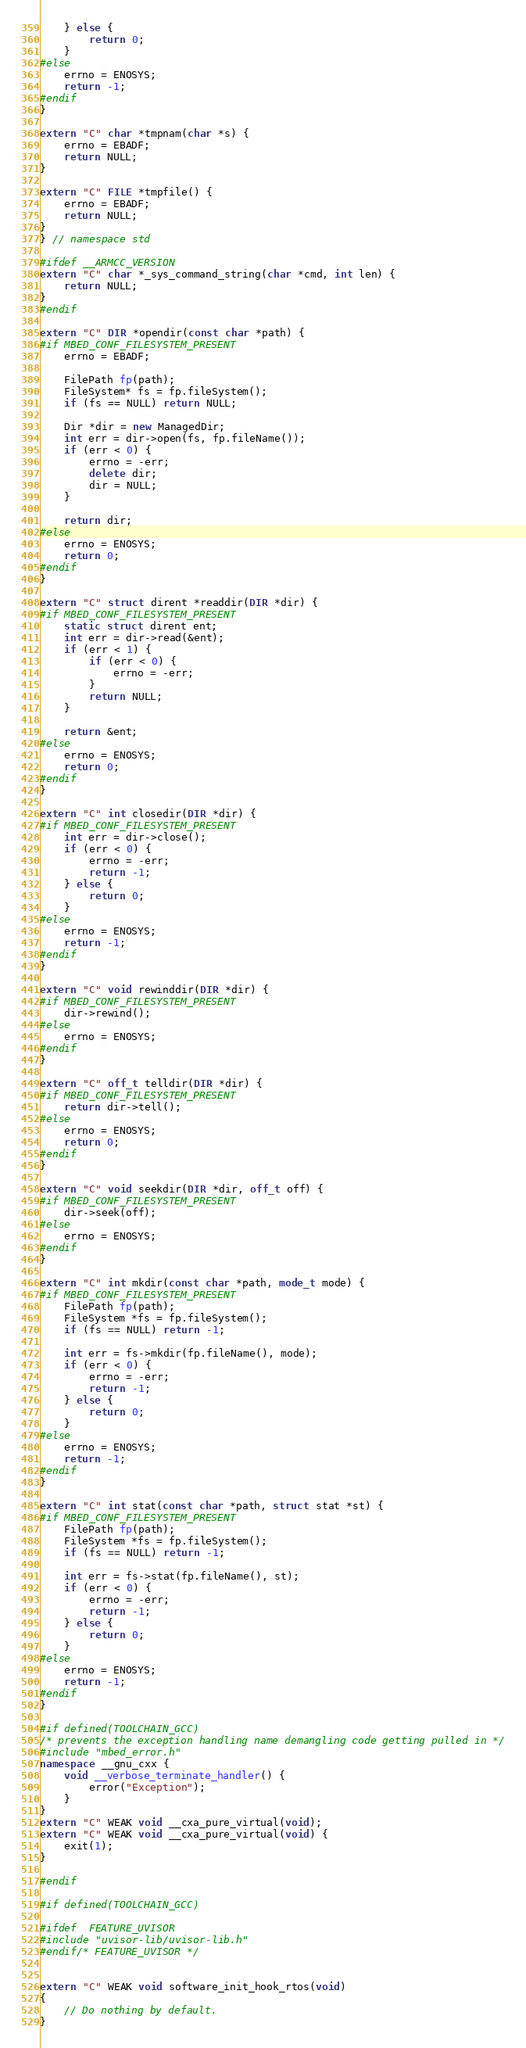Convert code to text. <code><loc_0><loc_0><loc_500><loc_500><_C++_>    } else {
        return 0;
    }
#else
    errno = ENOSYS;
    return -1;
#endif
}

extern "C" char *tmpnam(char *s) {
    errno = EBADF;
    return NULL;
}

extern "C" FILE *tmpfile() {
    errno = EBADF;
    return NULL;
}
} // namespace std

#ifdef __ARMCC_VERSION
extern "C" char *_sys_command_string(char *cmd, int len) {
    return NULL;
}
#endif

extern "C" DIR *opendir(const char *path) {
#if MBED_CONF_FILESYSTEM_PRESENT
    errno = EBADF;

    FilePath fp(path);
    FileSystem* fs = fp.fileSystem();
    if (fs == NULL) return NULL;

    Dir *dir = new ManagedDir;
    int err = dir->open(fs, fp.fileName());
    if (err < 0) {
        errno = -err;
        delete dir;
        dir = NULL;
    }

    return dir;
#else
    errno = ENOSYS;
    return 0;
#endif
}

extern "C" struct dirent *readdir(DIR *dir) {
#if MBED_CONF_FILESYSTEM_PRESENT
    static struct dirent ent;
    int err = dir->read(&ent);
    if (err < 1) {
        if (err < 0) {
            errno = -err;
        }
        return NULL;
    }

    return &ent;
#else
    errno = ENOSYS;
    return 0;
#endif
}

extern "C" int closedir(DIR *dir) {
#if MBED_CONF_FILESYSTEM_PRESENT
    int err = dir->close();
    if (err < 0) {
        errno = -err;
        return -1;
    } else {
        return 0;
    }
#else
    errno = ENOSYS;
    return -1;
#endif
}

extern "C" void rewinddir(DIR *dir) {
#if MBED_CONF_FILESYSTEM_PRESENT
    dir->rewind();
#else
    errno = ENOSYS;
#endif
}

extern "C" off_t telldir(DIR *dir) {
#if MBED_CONF_FILESYSTEM_PRESENT
    return dir->tell();
#else
    errno = ENOSYS;
    return 0;
#endif
}

extern "C" void seekdir(DIR *dir, off_t off) {
#if MBED_CONF_FILESYSTEM_PRESENT
    dir->seek(off);
#else
    errno = ENOSYS;
#endif
}

extern "C" int mkdir(const char *path, mode_t mode) {
#if MBED_CONF_FILESYSTEM_PRESENT
    FilePath fp(path);
    FileSystem *fs = fp.fileSystem();
    if (fs == NULL) return -1;

    int err = fs->mkdir(fp.fileName(), mode);
    if (err < 0) {
        errno = -err;
        return -1;
    } else {
        return 0;
    }
#else
    errno = ENOSYS;
    return -1;
#endif
}

extern "C" int stat(const char *path, struct stat *st) {
#if MBED_CONF_FILESYSTEM_PRESENT
    FilePath fp(path);
    FileSystem *fs = fp.fileSystem();
    if (fs == NULL) return -1;

    int err = fs->stat(fp.fileName(), st);
    if (err < 0) {
        errno = -err;
        return -1;
    } else {
        return 0;
    }
#else
    errno = ENOSYS;
    return -1;
#endif
}

#if defined(TOOLCHAIN_GCC)
/* prevents the exception handling name demangling code getting pulled in */
#include "mbed_error.h"
namespace __gnu_cxx {
    void __verbose_terminate_handler() {
        error("Exception");
    }
}
extern "C" WEAK void __cxa_pure_virtual(void);
extern "C" WEAK void __cxa_pure_virtual(void) {
    exit(1);
}

#endif

#if defined(TOOLCHAIN_GCC)

#ifdef  FEATURE_UVISOR
#include "uvisor-lib/uvisor-lib.h"
#endif/* FEATURE_UVISOR */


extern "C" WEAK void software_init_hook_rtos(void)
{
    // Do nothing by default.
}
</code> 